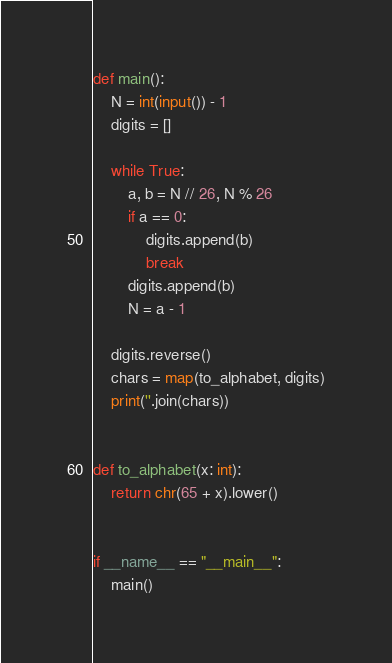<code> <loc_0><loc_0><loc_500><loc_500><_Python_>def main():
    N = int(input()) - 1
    digits = []

    while True:
        a, b = N // 26, N % 26
        if a == 0:
            digits.append(b)
            break
        digits.append(b)
        N = a - 1

    digits.reverse()
    chars = map(to_alphabet, digits)
    print(''.join(chars))


def to_alphabet(x: int):
    return chr(65 + x).lower()


if __name__ == "__main__":
    main()
</code> 